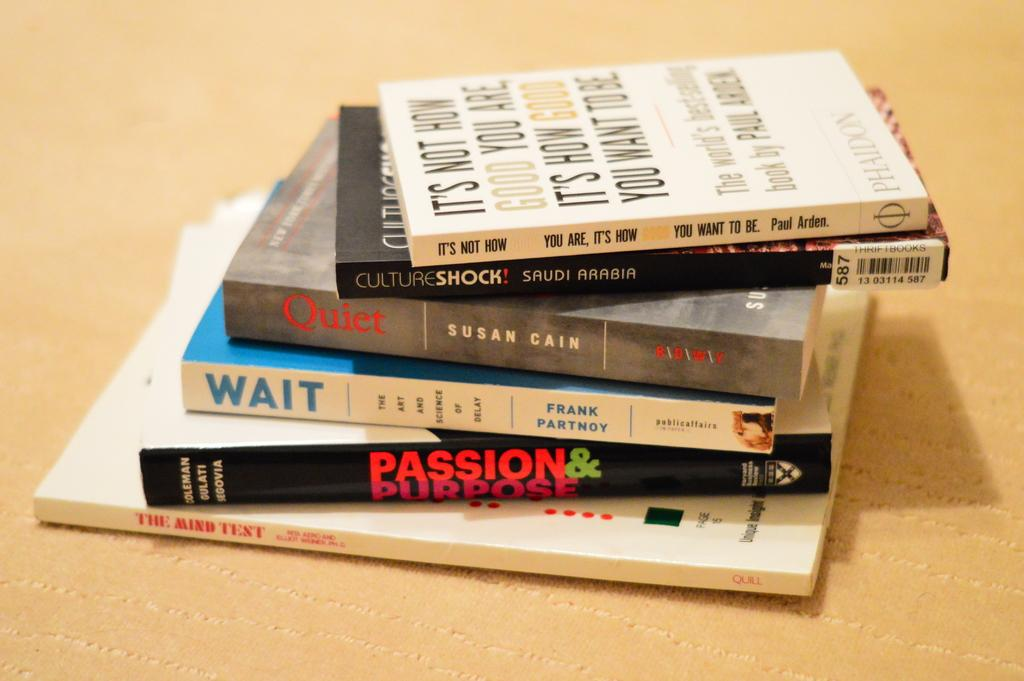<image>
Give a short and clear explanation of the subsequent image. a book showing passion and purpose is shown 